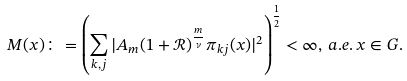Convert formula to latex. <formula><loc_0><loc_0><loc_500><loc_500>M ( x ) \colon = \left ( \sum _ { k , j } | A _ { m } ( 1 + \mathcal { R } ) ^ { \frac { m } { \nu } } \pi _ { k j } ( x ) | ^ { 2 } \right ) ^ { \frac { 1 } { 2 } } < \infty , \, a . e . \, x \in G .</formula> 